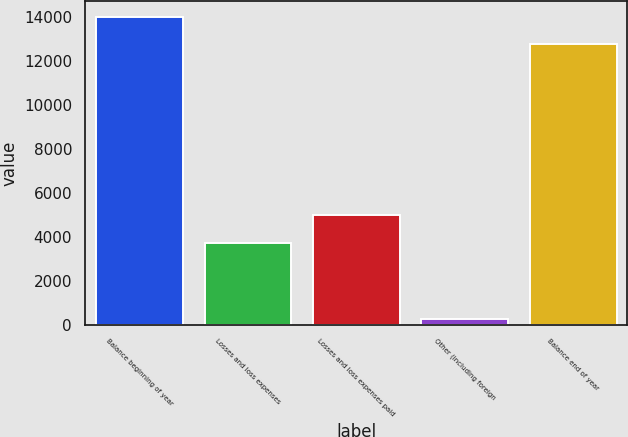Convert chart to OTSL. <chart><loc_0><loc_0><loc_500><loc_500><bar_chart><fcel>Balance beginning of year<fcel>Losses and loss expenses<fcel>Losses and loss expenses paid<fcel>Other (including foreign<fcel>Balance end of year<nl><fcel>14014.9<fcel>3719<fcel>4988.9<fcel>236<fcel>12745<nl></chart> 